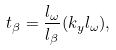<formula> <loc_0><loc_0><loc_500><loc_500>t _ { \beta } = \frac { l _ { \omega } } { l _ { \beta } } ( k _ { y } l _ { \omega } ) ,</formula> 